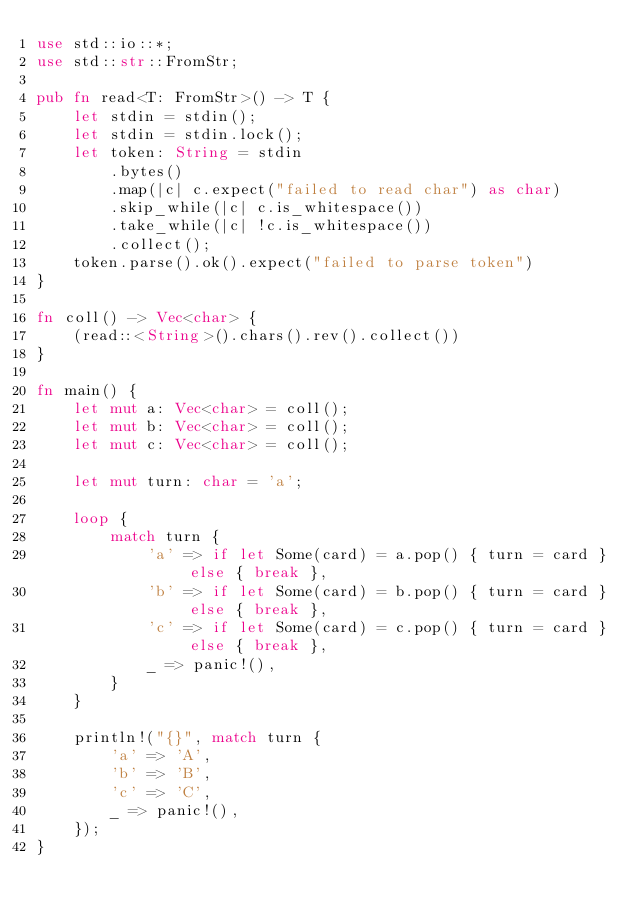<code> <loc_0><loc_0><loc_500><loc_500><_Rust_>use std::io::*;
use std::str::FromStr;

pub fn read<T: FromStr>() -> T {
    let stdin = stdin();
    let stdin = stdin.lock();
    let token: String = stdin
        .bytes()
        .map(|c| c.expect("failed to read char") as char) 
        .skip_while(|c| c.is_whitespace())
        .take_while(|c| !c.is_whitespace())
        .collect();
    token.parse().ok().expect("failed to parse token")
}

fn coll() -> Vec<char> {
    (read::<String>().chars().rev().collect())
}

fn main() {
    let mut a: Vec<char> = coll();
    let mut b: Vec<char> = coll();
    let mut c: Vec<char> = coll();

    let mut turn: char = 'a';

    loop {
        match turn {
            'a' => if let Some(card) = a.pop() { turn = card } else { break },
            'b' => if let Some(card) = b.pop() { turn = card } else { break },
            'c' => if let Some(card) = c.pop() { turn = card } else { break },
            _ => panic!(),
        }
    }

    println!("{}", match turn {
        'a' => 'A',
        'b' => 'B',
        'c' => 'C',
        _ => panic!(),
    });
}
</code> 